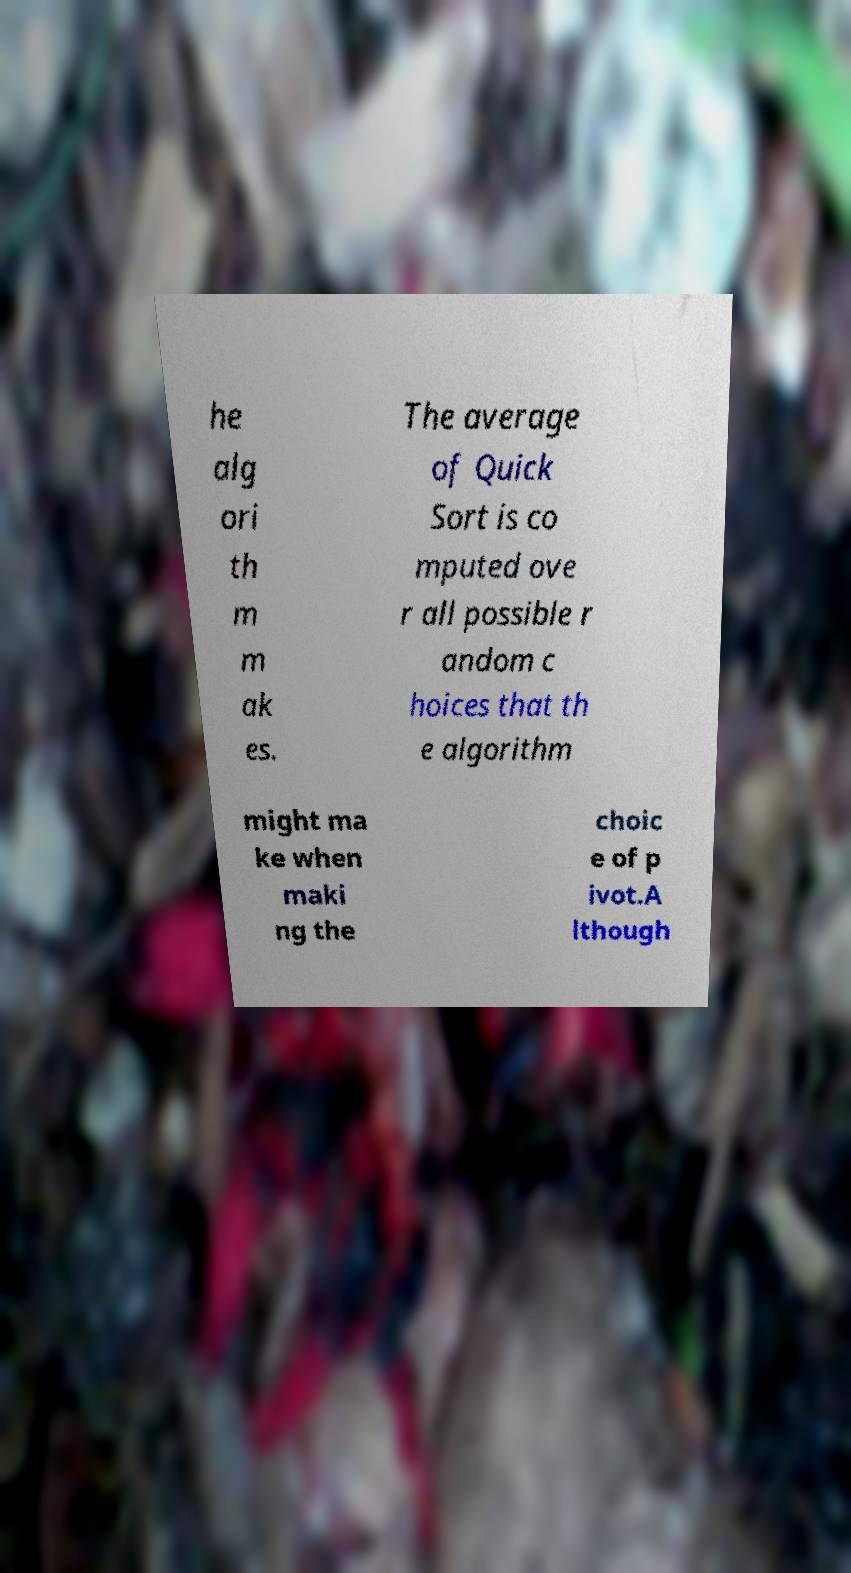Please read and relay the text visible in this image. What does it say? he alg ori th m m ak es. The average of Quick Sort is co mputed ove r all possible r andom c hoices that th e algorithm might ma ke when maki ng the choic e of p ivot.A lthough 